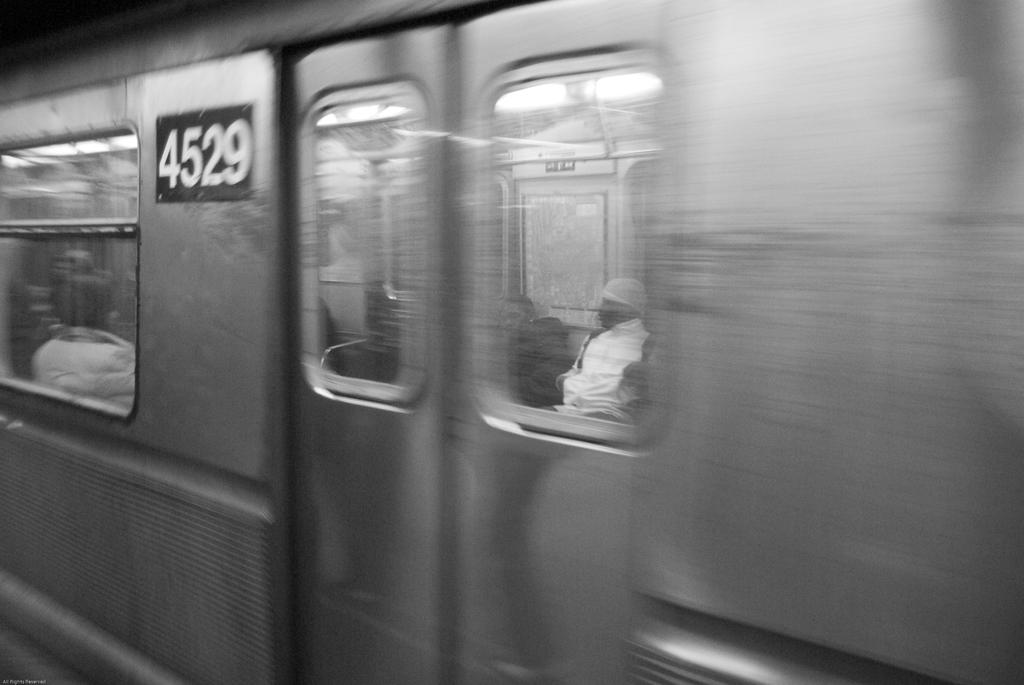Provide a one-sentence caption for the provided image. Train with a 4529 that have people on it. 